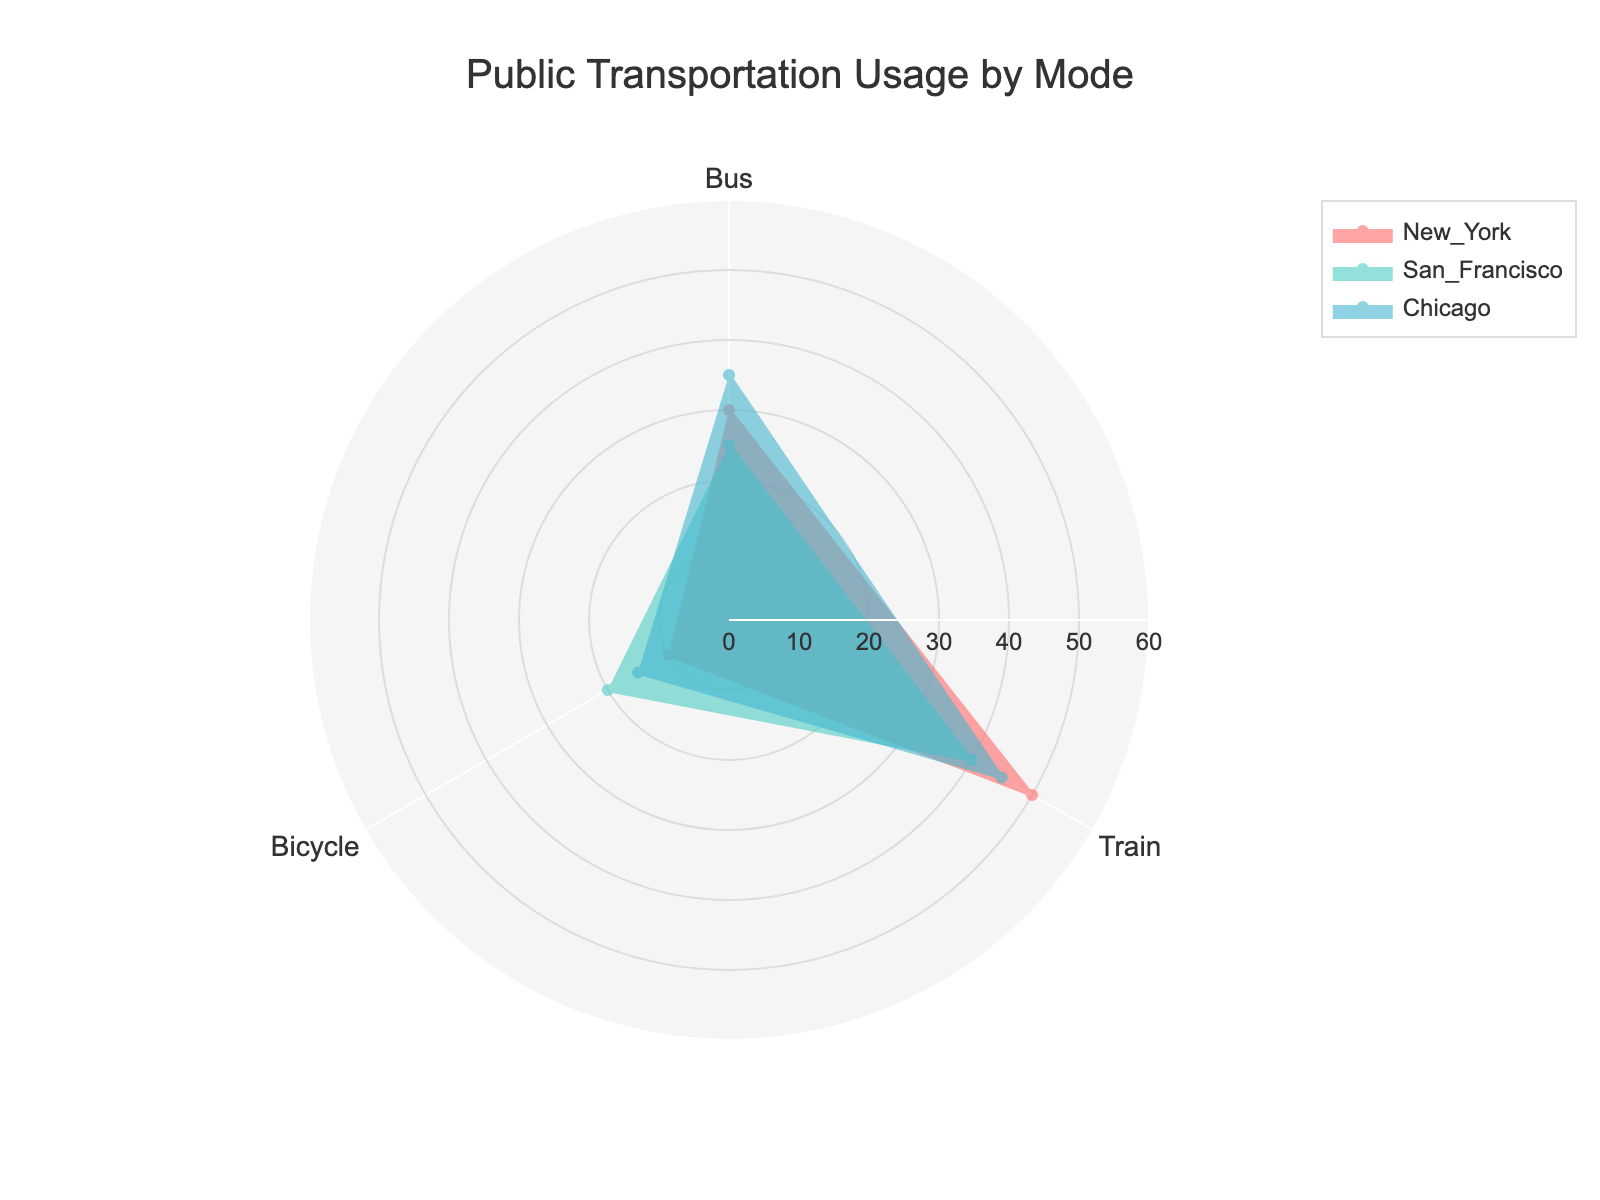What's the title of the chart? The title of the chart is written at the top center of the figure. It provides a brief summary of what the chart represents, making it easy to understand the subject of the visualization.
Answer: Public Transportation Usage by Mode How many different transportation modes are represented in the chart? The transportation modes are represented as the categories in the radar chart. By looking at the axes coming out of the center, we can count the number of different transportation modes.
Answer: 3 Which group has the highest bus usage? Identify the group with the maximum value along the Bus axis. This requires observing the length of each group's marker on the Bus axis, and comparing them.
Answer: Chicago Which group has the lowest train usage? Identify the group with the minimum value along the Train axis. This involves observing the lengths of the markers for each group on the Train axis and finding the shortest one.
Answer: San Francisco What is the sum of bicycle usage for all groups combined? To calculate the total bicycle usage, sum up the values for the Bicycle mode for all the groups listed in the chart: New York (10), San Francisco (20), and Chicago (15).
Answer: 45 Which group is using buses more than 30 units? Compare the bus usage values of New York, San Francisco, and Chicago to 30 units. Identify the groups where bus usage exceeds 30 units.
Answer: New York, Chicago Does any group use the bicycle more frequently than the bus? Compare the values of Bicycle and Bus usage for each group separately to see if there is any group where Bicycle usage exceeds Bus usage.
Answer: No What is the average train usage among the groups? Calculate the average by summing the train usage values for New York (50), San Francisco (40), and Chicago (45) and dividing by the number of groups (3). (50 + 40 + 45) / 3 = 45
Answer: 45 